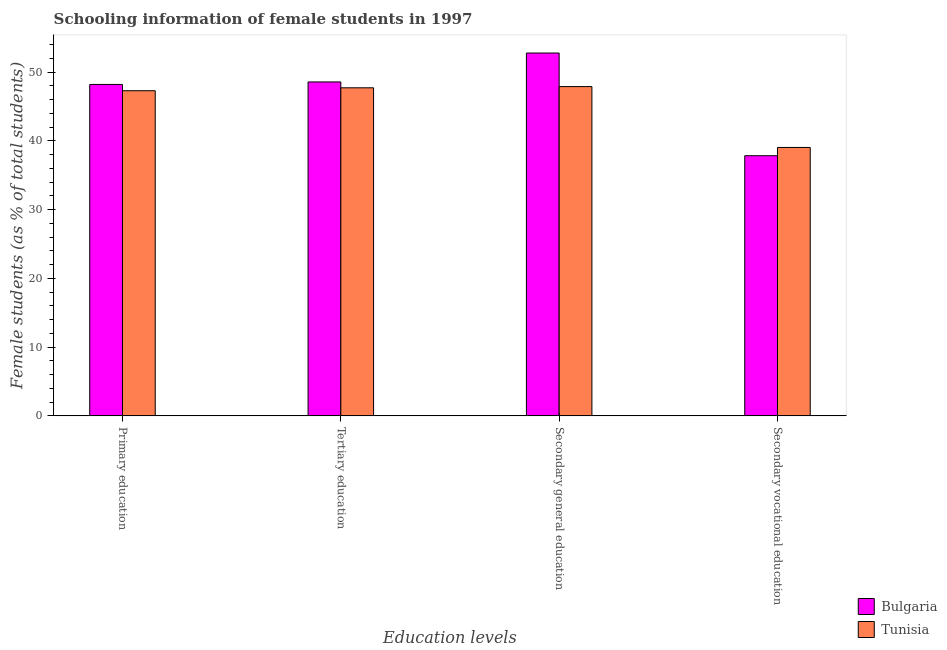How many different coloured bars are there?
Your answer should be very brief. 2. Are the number of bars per tick equal to the number of legend labels?
Your response must be concise. Yes. Are the number of bars on each tick of the X-axis equal?
Offer a terse response. Yes. How many bars are there on the 3rd tick from the right?
Ensure brevity in your answer.  2. What is the label of the 4th group of bars from the left?
Your answer should be compact. Secondary vocational education. What is the percentage of female students in secondary education in Tunisia?
Your answer should be very brief. 47.88. Across all countries, what is the maximum percentage of female students in primary education?
Make the answer very short. 48.19. Across all countries, what is the minimum percentage of female students in secondary education?
Your answer should be very brief. 47.88. In which country was the percentage of female students in secondary vocational education minimum?
Offer a terse response. Bulgaria. What is the total percentage of female students in primary education in the graph?
Keep it short and to the point. 95.47. What is the difference between the percentage of female students in secondary education in Tunisia and that in Bulgaria?
Your answer should be compact. -4.88. What is the difference between the percentage of female students in tertiary education in Bulgaria and the percentage of female students in secondary education in Tunisia?
Your answer should be compact. 0.67. What is the average percentage of female students in tertiary education per country?
Your answer should be very brief. 48.13. What is the difference between the percentage of female students in tertiary education and percentage of female students in secondary education in Bulgaria?
Offer a very short reply. -4.21. In how many countries, is the percentage of female students in secondary education greater than 36 %?
Provide a short and direct response. 2. What is the ratio of the percentage of female students in secondary education in Bulgaria to that in Tunisia?
Make the answer very short. 1.1. Is the difference between the percentage of female students in secondary vocational education in Bulgaria and Tunisia greater than the difference between the percentage of female students in tertiary education in Bulgaria and Tunisia?
Provide a succinct answer. No. What is the difference between the highest and the second highest percentage of female students in secondary education?
Keep it short and to the point. 4.88. What is the difference between the highest and the lowest percentage of female students in primary education?
Ensure brevity in your answer.  0.92. In how many countries, is the percentage of female students in secondary vocational education greater than the average percentage of female students in secondary vocational education taken over all countries?
Ensure brevity in your answer.  1. Is it the case that in every country, the sum of the percentage of female students in primary education and percentage of female students in secondary education is greater than the sum of percentage of female students in secondary vocational education and percentage of female students in tertiary education?
Ensure brevity in your answer.  No. What does the 1st bar from the left in Secondary vocational education represents?
Your answer should be very brief. Bulgaria. Is it the case that in every country, the sum of the percentage of female students in primary education and percentage of female students in tertiary education is greater than the percentage of female students in secondary education?
Keep it short and to the point. Yes. Are all the bars in the graph horizontal?
Ensure brevity in your answer.  No. Are the values on the major ticks of Y-axis written in scientific E-notation?
Make the answer very short. No. Where does the legend appear in the graph?
Ensure brevity in your answer.  Bottom right. What is the title of the graph?
Ensure brevity in your answer.  Schooling information of female students in 1997. Does "Myanmar" appear as one of the legend labels in the graph?
Offer a terse response. No. What is the label or title of the X-axis?
Your answer should be very brief. Education levels. What is the label or title of the Y-axis?
Give a very brief answer. Female students (as % of total students). What is the Female students (as % of total students) in Bulgaria in Primary education?
Keep it short and to the point. 48.19. What is the Female students (as % of total students) in Tunisia in Primary education?
Your answer should be compact. 47.28. What is the Female students (as % of total students) in Bulgaria in Tertiary education?
Offer a very short reply. 48.55. What is the Female students (as % of total students) in Tunisia in Tertiary education?
Provide a short and direct response. 47.7. What is the Female students (as % of total students) in Bulgaria in Secondary general education?
Keep it short and to the point. 52.76. What is the Female students (as % of total students) of Tunisia in Secondary general education?
Offer a very short reply. 47.88. What is the Female students (as % of total students) in Bulgaria in Secondary vocational education?
Give a very brief answer. 37.83. What is the Female students (as % of total students) in Tunisia in Secondary vocational education?
Your response must be concise. 39.03. Across all Education levels, what is the maximum Female students (as % of total students) in Bulgaria?
Provide a succinct answer. 52.76. Across all Education levels, what is the maximum Female students (as % of total students) of Tunisia?
Your response must be concise. 47.88. Across all Education levels, what is the minimum Female students (as % of total students) in Bulgaria?
Offer a very short reply. 37.83. Across all Education levels, what is the minimum Female students (as % of total students) in Tunisia?
Keep it short and to the point. 39.03. What is the total Female students (as % of total students) in Bulgaria in the graph?
Your answer should be very brief. 187.34. What is the total Female students (as % of total students) of Tunisia in the graph?
Ensure brevity in your answer.  181.89. What is the difference between the Female students (as % of total students) of Bulgaria in Primary education and that in Tertiary education?
Make the answer very short. -0.36. What is the difference between the Female students (as % of total students) in Tunisia in Primary education and that in Tertiary education?
Offer a very short reply. -0.43. What is the difference between the Female students (as % of total students) of Bulgaria in Primary education and that in Secondary general education?
Provide a succinct answer. -4.57. What is the difference between the Female students (as % of total students) of Tunisia in Primary education and that in Secondary general education?
Your response must be concise. -0.6. What is the difference between the Female students (as % of total students) in Bulgaria in Primary education and that in Secondary vocational education?
Your answer should be very brief. 10.36. What is the difference between the Female students (as % of total students) in Tunisia in Primary education and that in Secondary vocational education?
Your response must be concise. 8.25. What is the difference between the Female students (as % of total students) of Bulgaria in Tertiary education and that in Secondary general education?
Provide a short and direct response. -4.21. What is the difference between the Female students (as % of total students) in Tunisia in Tertiary education and that in Secondary general education?
Make the answer very short. -0.18. What is the difference between the Female students (as % of total students) of Bulgaria in Tertiary education and that in Secondary vocational education?
Offer a very short reply. 10.73. What is the difference between the Female students (as % of total students) in Tunisia in Tertiary education and that in Secondary vocational education?
Provide a succinct answer. 8.68. What is the difference between the Female students (as % of total students) of Bulgaria in Secondary general education and that in Secondary vocational education?
Ensure brevity in your answer.  14.93. What is the difference between the Female students (as % of total students) of Tunisia in Secondary general education and that in Secondary vocational education?
Ensure brevity in your answer.  8.85. What is the difference between the Female students (as % of total students) in Bulgaria in Primary education and the Female students (as % of total students) in Tunisia in Tertiary education?
Ensure brevity in your answer.  0.49. What is the difference between the Female students (as % of total students) of Bulgaria in Primary education and the Female students (as % of total students) of Tunisia in Secondary general education?
Your answer should be very brief. 0.31. What is the difference between the Female students (as % of total students) of Bulgaria in Primary education and the Female students (as % of total students) of Tunisia in Secondary vocational education?
Ensure brevity in your answer.  9.16. What is the difference between the Female students (as % of total students) of Bulgaria in Tertiary education and the Female students (as % of total students) of Tunisia in Secondary general education?
Your answer should be very brief. 0.67. What is the difference between the Female students (as % of total students) of Bulgaria in Tertiary education and the Female students (as % of total students) of Tunisia in Secondary vocational education?
Ensure brevity in your answer.  9.53. What is the difference between the Female students (as % of total students) of Bulgaria in Secondary general education and the Female students (as % of total students) of Tunisia in Secondary vocational education?
Keep it short and to the point. 13.73. What is the average Female students (as % of total students) of Bulgaria per Education levels?
Provide a succinct answer. 46.83. What is the average Female students (as % of total students) of Tunisia per Education levels?
Provide a short and direct response. 45.47. What is the difference between the Female students (as % of total students) in Bulgaria and Female students (as % of total students) in Tunisia in Primary education?
Ensure brevity in your answer.  0.92. What is the difference between the Female students (as % of total students) in Bulgaria and Female students (as % of total students) in Tunisia in Tertiary education?
Ensure brevity in your answer.  0.85. What is the difference between the Female students (as % of total students) in Bulgaria and Female students (as % of total students) in Tunisia in Secondary general education?
Make the answer very short. 4.88. What is the difference between the Female students (as % of total students) in Bulgaria and Female students (as % of total students) in Tunisia in Secondary vocational education?
Make the answer very short. -1.2. What is the ratio of the Female students (as % of total students) in Tunisia in Primary education to that in Tertiary education?
Ensure brevity in your answer.  0.99. What is the ratio of the Female students (as % of total students) in Bulgaria in Primary education to that in Secondary general education?
Ensure brevity in your answer.  0.91. What is the ratio of the Female students (as % of total students) in Tunisia in Primary education to that in Secondary general education?
Your answer should be very brief. 0.99. What is the ratio of the Female students (as % of total students) in Bulgaria in Primary education to that in Secondary vocational education?
Your response must be concise. 1.27. What is the ratio of the Female students (as % of total students) of Tunisia in Primary education to that in Secondary vocational education?
Offer a very short reply. 1.21. What is the ratio of the Female students (as % of total students) in Bulgaria in Tertiary education to that in Secondary general education?
Provide a succinct answer. 0.92. What is the ratio of the Female students (as % of total students) of Bulgaria in Tertiary education to that in Secondary vocational education?
Offer a terse response. 1.28. What is the ratio of the Female students (as % of total students) of Tunisia in Tertiary education to that in Secondary vocational education?
Provide a short and direct response. 1.22. What is the ratio of the Female students (as % of total students) in Bulgaria in Secondary general education to that in Secondary vocational education?
Keep it short and to the point. 1.39. What is the ratio of the Female students (as % of total students) of Tunisia in Secondary general education to that in Secondary vocational education?
Make the answer very short. 1.23. What is the difference between the highest and the second highest Female students (as % of total students) of Bulgaria?
Your answer should be very brief. 4.21. What is the difference between the highest and the second highest Female students (as % of total students) of Tunisia?
Provide a short and direct response. 0.18. What is the difference between the highest and the lowest Female students (as % of total students) in Bulgaria?
Offer a very short reply. 14.93. What is the difference between the highest and the lowest Female students (as % of total students) of Tunisia?
Ensure brevity in your answer.  8.85. 